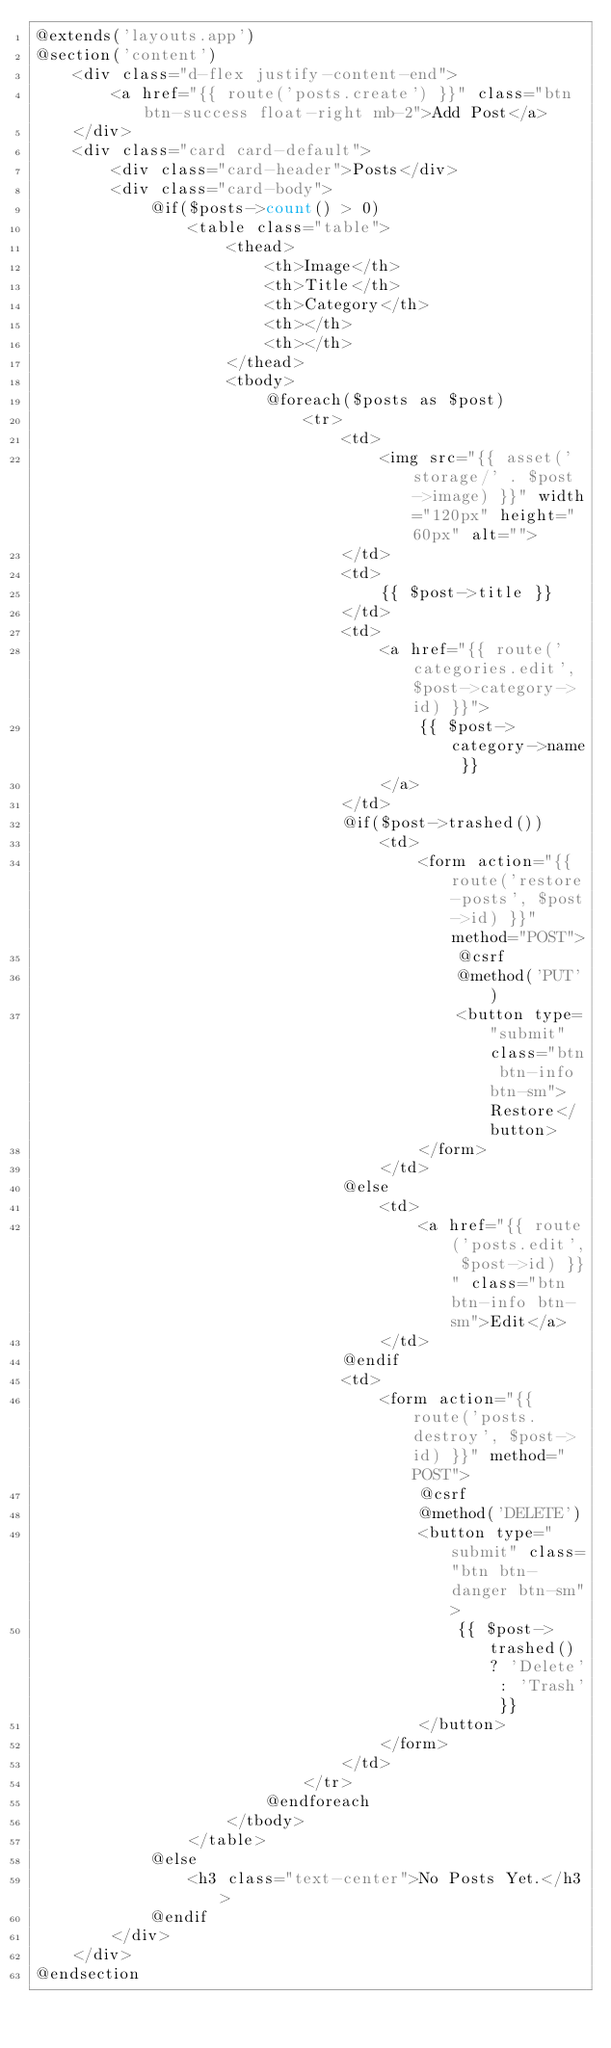<code> <loc_0><loc_0><loc_500><loc_500><_PHP_>@extends('layouts.app')
@section('content')
    <div class="d-flex justify-content-end">
        <a href="{{ route('posts.create') }}" class="btn btn-success float-right mb-2">Add Post</a>
    </div>
    <div class="card card-default">
        <div class="card-header">Posts</div>
        <div class="card-body">
            @if($posts->count() > 0)
                <table class="table">
                    <thead>
                        <th>Image</th>
                        <th>Title</th>
                        <th>Category</th>
                        <th></th>
                        <th></th>
                    </thead>
                    <tbody>
                        @foreach($posts as $post)
                            <tr>
                                <td>
                                    <img src="{{ asset('storage/' . $post->image) }}" width="120px" height="60px" alt="">
                                </td>
                                <td>
                                    {{ $post->title }}
                                </td>
                                <td>
                                    <a href="{{ route('categories.edit', $post->category->id) }}">
                                        {{ $post->category->name }}
                                    </a>
                                </td>
                                @if($post->trashed())
                                    <td>
                                        <form action="{{ route('restore-posts', $post->id) }}" method="POST">
                                            @csrf
                                            @method('PUT')
                                            <button type="submit" class="btn btn-info btn-sm">Restore</button>
                                        </form>
                                    </td>
                                @else
                                    <td>
                                        <a href="{{ route('posts.edit', $post->id) }}" class="btn btn-info btn-sm">Edit</a>
                                    </td>
                                @endif
                                <td>
                                    <form action="{{ route('posts.destroy', $post->id) }}" method="POST">
                                        @csrf
                                        @method('DELETE')
                                        <button type="submit" class="btn btn-danger btn-sm">
                                            {{ $post->trashed() ? 'Delete' : 'Trash' }}
                                        </button>
                                    </form>
                                </td>
                            </tr>
                        @endforeach
                    </tbody>
                </table>
            @else
                <h3 class="text-center">No Posts Yet.</h3>
            @endif
        </div>
    </div>
@endsection</code> 